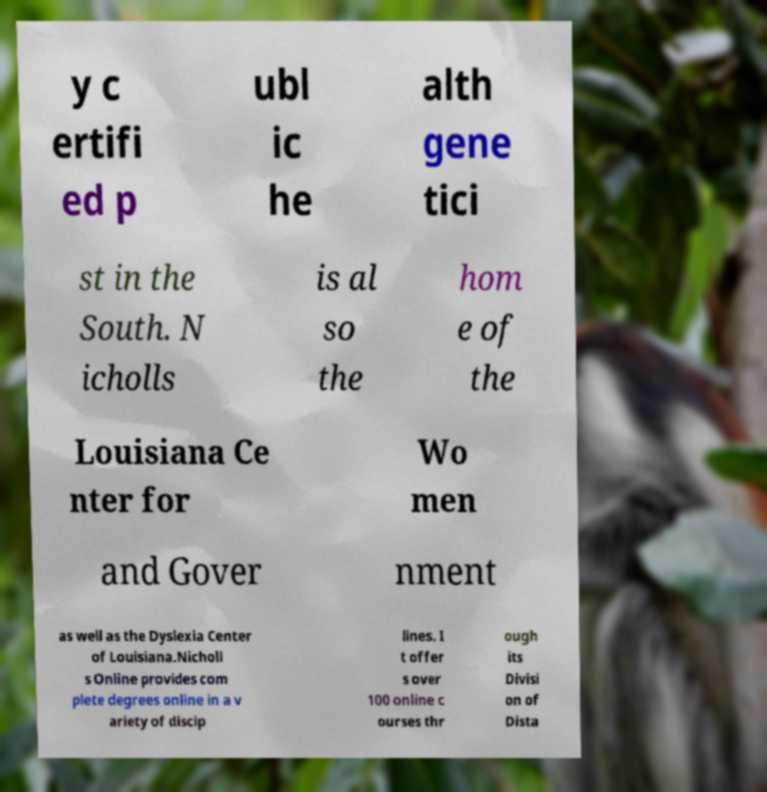Can you accurately transcribe the text from the provided image for me? y c ertifi ed p ubl ic he alth gene tici st in the South. N icholls is al so the hom e of the Louisiana Ce nter for Wo men and Gover nment as well as the Dyslexia Center of Louisiana.Nicholl s Online provides com plete degrees online in a v ariety of discip lines. I t offer s over 100 online c ourses thr ough its Divisi on of Dista 